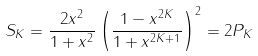Convert formula to latex. <formula><loc_0><loc_0><loc_500><loc_500>S _ { K } = \frac { 2 x ^ { 2 } } { 1 + x ^ { 2 } } \left ( \frac { 1 - x ^ { 2 K } } { 1 + x ^ { 2 K + 1 } } \right ) ^ { 2 } = 2 P _ { K }</formula> 